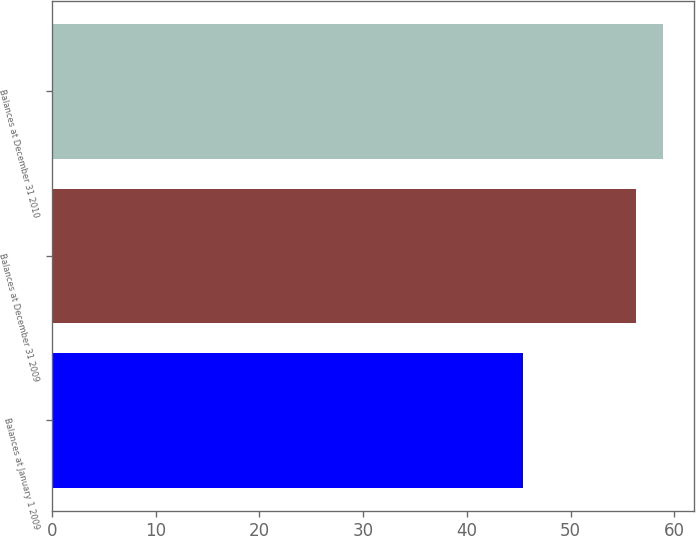Convert chart. <chart><loc_0><loc_0><loc_500><loc_500><bar_chart><fcel>Balances at January 1 2009<fcel>Balances at December 31 2009<fcel>Balances at December 31 2010<nl><fcel>45.4<fcel>56.3<fcel>58.9<nl></chart> 